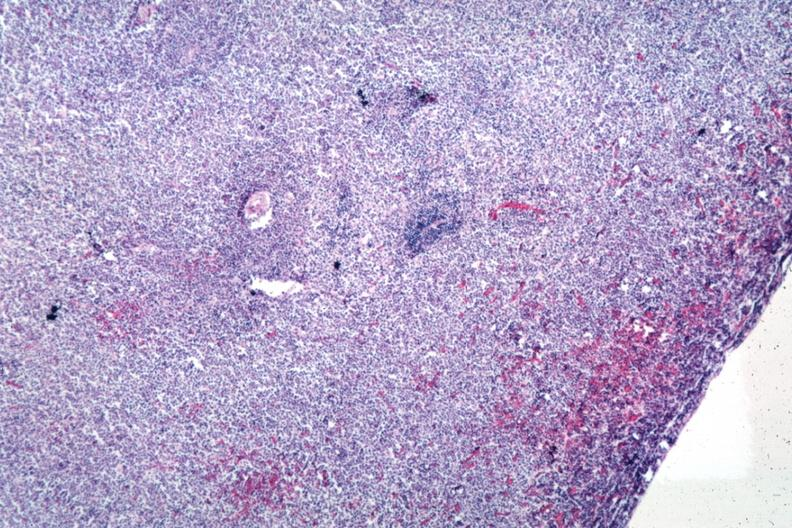does this image show sheets of lymphoma cells?
Answer the question using a single word or phrase. Yes 